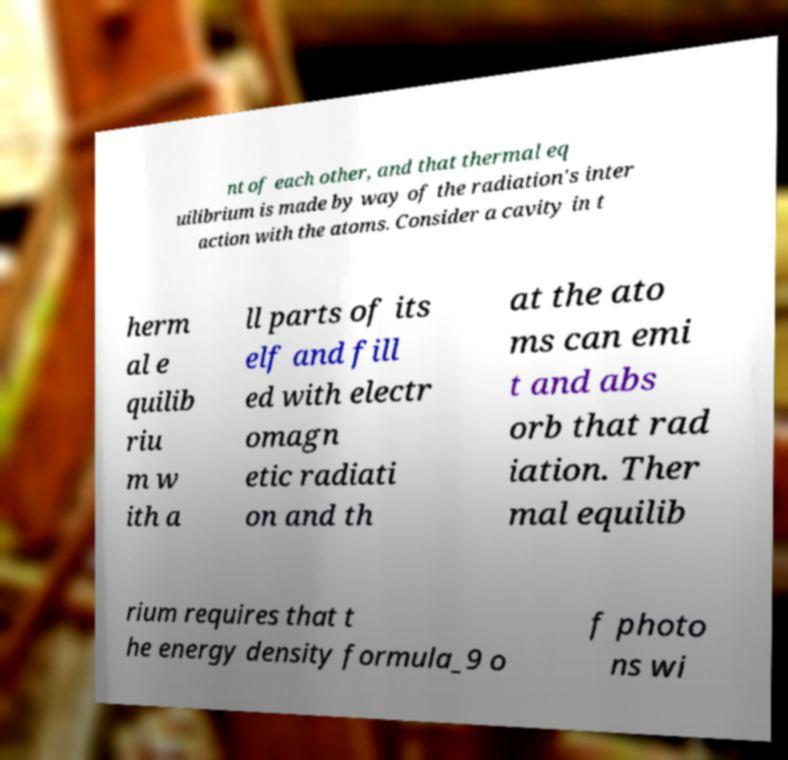Please identify and transcribe the text found in this image. nt of each other, and that thermal eq uilibrium is made by way of the radiation's inter action with the atoms. Consider a cavity in t herm al e quilib riu m w ith a ll parts of its elf and fill ed with electr omagn etic radiati on and th at the ato ms can emi t and abs orb that rad iation. Ther mal equilib rium requires that t he energy density formula_9 o f photo ns wi 